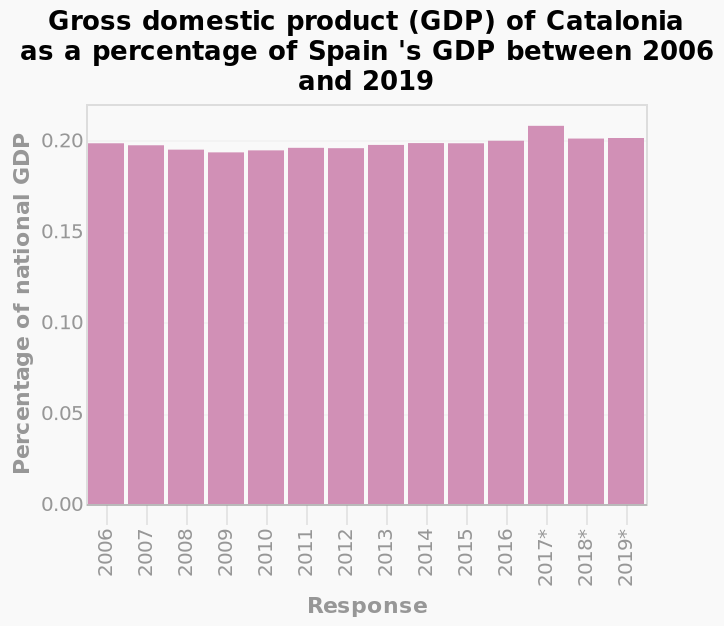<image>
What does the x-axis measure in the bar diagram? The x-axis measures the response using a categorical scale from 2006 to 2019. What does the y-axis show in the bar diagram? The y-axis shows the percentage of national GDP as a linear scale from 0.00 to 0.20. What is the name of the bar diagram described here? The bar diagram is called Gross domestic product (GDP) of Catalonia as a percentage of Spain's GDP between 2006 and 2019. 